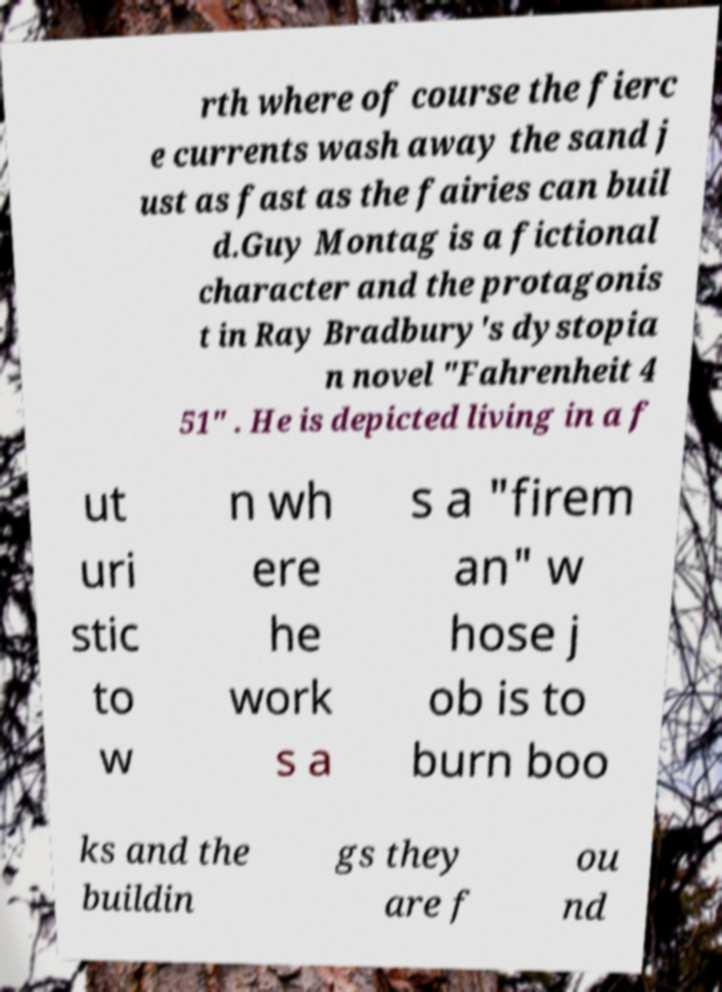I need the written content from this picture converted into text. Can you do that? rth where of course the fierc e currents wash away the sand j ust as fast as the fairies can buil d.Guy Montag is a fictional character and the protagonis t in Ray Bradbury's dystopia n novel "Fahrenheit 4 51" . He is depicted living in a f ut uri stic to w n wh ere he work s a s a "firem an" w hose j ob is to burn boo ks and the buildin gs they are f ou nd 